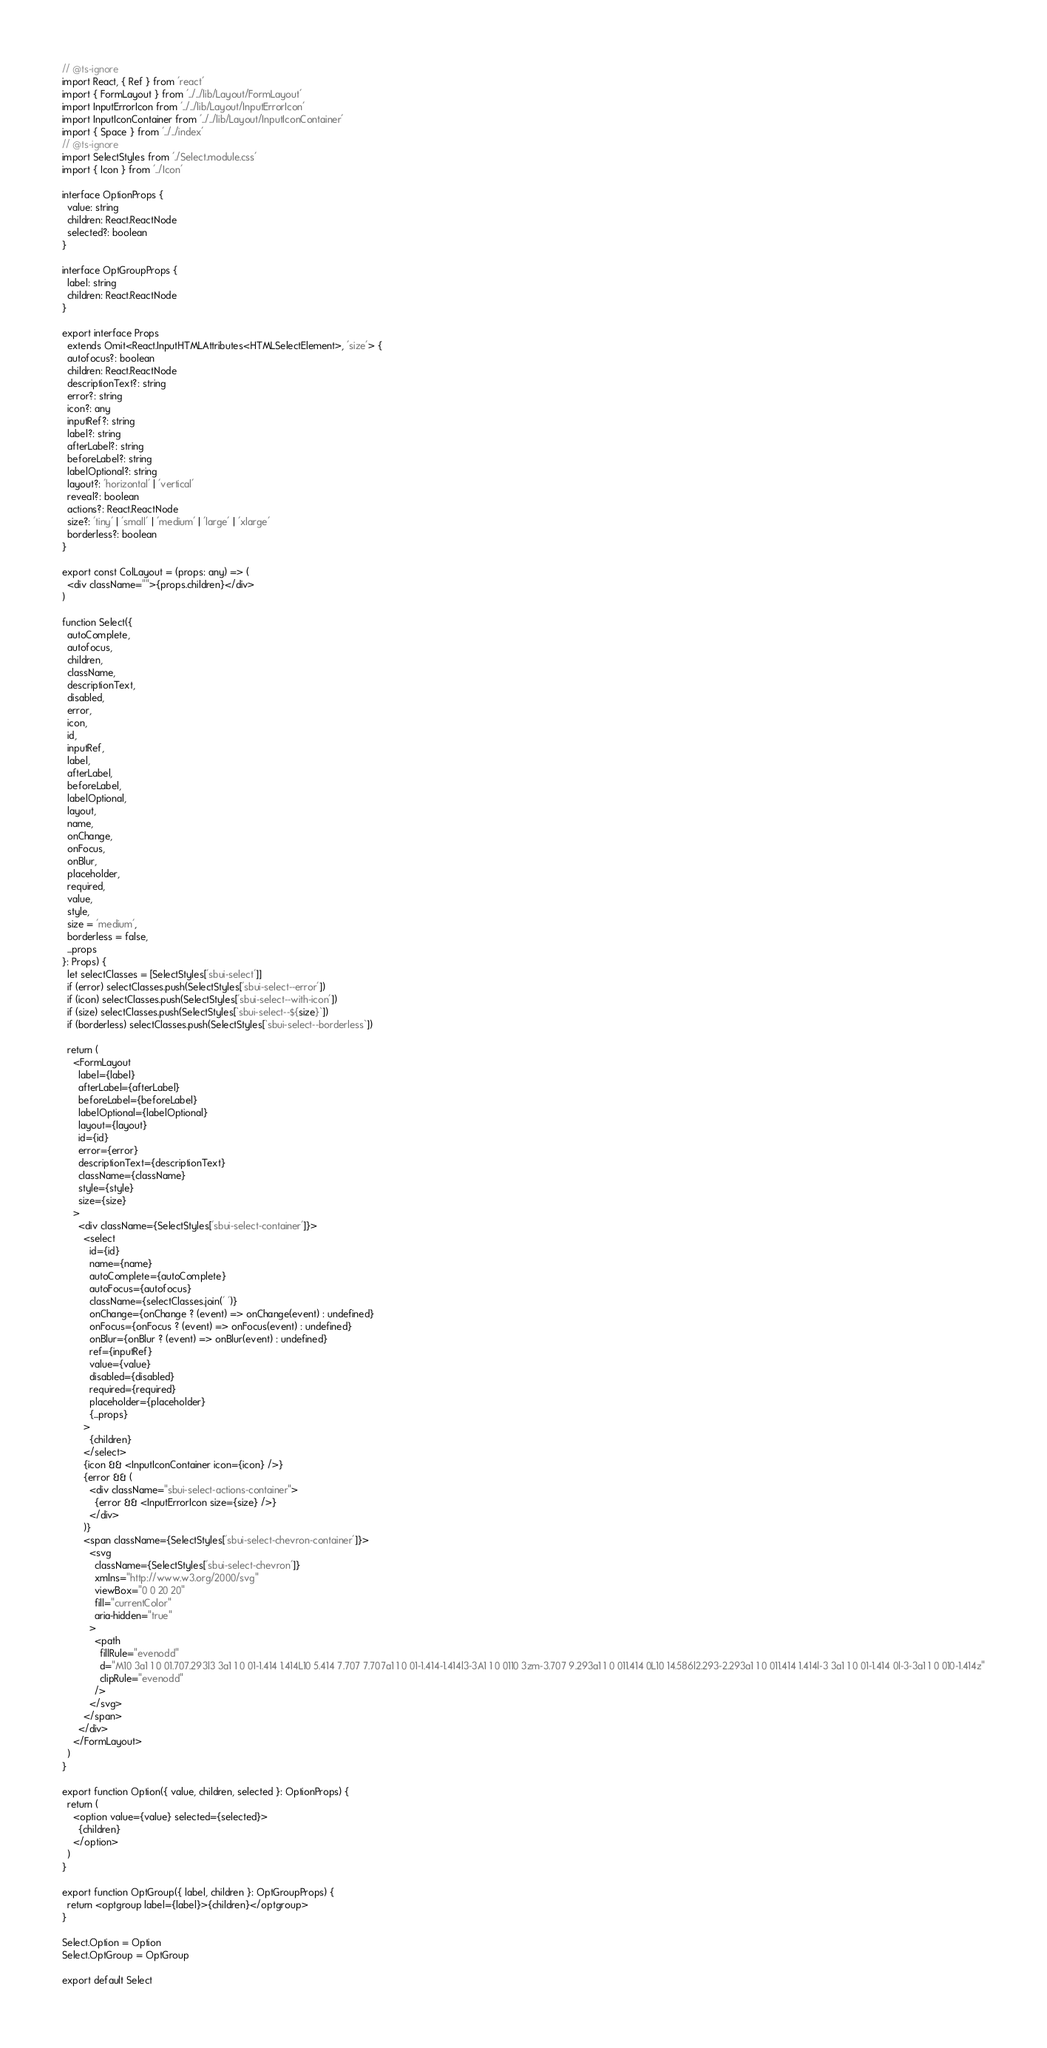Convert code to text. <code><loc_0><loc_0><loc_500><loc_500><_TypeScript_>// @ts-ignore
import React, { Ref } from 'react'
import { FormLayout } from '../../lib/Layout/FormLayout'
import InputErrorIcon from '../../lib/Layout/InputErrorIcon'
import InputIconContainer from '../../lib/Layout/InputIconContainer'
import { Space } from '../../index'
// @ts-ignore
import SelectStyles from './Select.module.css'
import { Icon } from '../Icon'

interface OptionProps {
  value: string
  children: React.ReactNode
  selected?: boolean
}

interface OptGroupProps {
  label: string
  children: React.ReactNode
}

export interface Props
  extends Omit<React.InputHTMLAttributes<HTMLSelectElement>, 'size'> {
  autofocus?: boolean
  children: React.ReactNode
  descriptionText?: string
  error?: string
  icon?: any
  inputRef?: string
  label?: string
  afterLabel?: string
  beforeLabel?: string
  labelOptional?: string
  layout?: 'horizontal' | 'vertical'
  reveal?: boolean
  actions?: React.ReactNode
  size?: 'tiny' | 'small' | 'medium' | 'large' | 'xlarge'
  borderless?: boolean
}

export const ColLayout = (props: any) => (
  <div className="">{props.children}</div>
)

function Select({
  autoComplete,
  autofocus,
  children,
  className,
  descriptionText,
  disabled,
  error,
  icon,
  id,
  inputRef,
  label,
  afterLabel,
  beforeLabel,
  labelOptional,
  layout,
  name,
  onChange,
  onFocus,
  onBlur,
  placeholder,
  required,
  value,
  style,
  size = 'medium',
  borderless = false,
  ...props
}: Props) {
  let selectClasses = [SelectStyles['sbui-select']]
  if (error) selectClasses.push(SelectStyles['sbui-select--error'])
  if (icon) selectClasses.push(SelectStyles['sbui-select--with-icon'])
  if (size) selectClasses.push(SelectStyles[`sbui-select--${size}`])
  if (borderless) selectClasses.push(SelectStyles[`sbui-select--borderless`])

  return (
    <FormLayout
      label={label}
      afterLabel={afterLabel}
      beforeLabel={beforeLabel}
      labelOptional={labelOptional}
      layout={layout}
      id={id}
      error={error}
      descriptionText={descriptionText}
      className={className}
      style={style}
      size={size}
    >
      <div className={SelectStyles['sbui-select-container']}>
        <select
          id={id}
          name={name}
          autoComplete={autoComplete}
          autoFocus={autofocus}
          className={selectClasses.join(' ')}
          onChange={onChange ? (event) => onChange(event) : undefined}
          onFocus={onFocus ? (event) => onFocus(event) : undefined}
          onBlur={onBlur ? (event) => onBlur(event) : undefined}
          ref={inputRef}
          value={value}
          disabled={disabled}
          required={required}
          placeholder={placeholder}
          {...props}
        >
          {children}
        </select>
        {icon && <InputIconContainer icon={icon} />}
        {error && (
          <div className="sbui-select-actions-container">
            {error && <InputErrorIcon size={size} />}
          </div>
        )}
        <span className={SelectStyles['sbui-select-chevron-container']}>
          <svg
            className={SelectStyles['sbui-select-chevron']}
            xmlns="http://www.w3.org/2000/svg"
            viewBox="0 0 20 20"
            fill="currentColor"
            aria-hidden="true"
          >
            <path
              fillRule="evenodd"
              d="M10 3a1 1 0 01.707.293l3 3a1 1 0 01-1.414 1.414L10 5.414 7.707 7.707a1 1 0 01-1.414-1.414l3-3A1 1 0 0110 3zm-3.707 9.293a1 1 0 011.414 0L10 14.586l2.293-2.293a1 1 0 011.414 1.414l-3 3a1 1 0 01-1.414 0l-3-3a1 1 0 010-1.414z"
              clipRule="evenodd"
            />
          </svg>
        </span>
      </div>
    </FormLayout>
  )
}

export function Option({ value, children, selected }: OptionProps) {
  return (
    <option value={value} selected={selected}>
      {children}
    </option>
  )
}

export function OptGroup({ label, children }: OptGroupProps) {
  return <optgroup label={label}>{children}</optgroup>
}

Select.Option = Option
Select.OptGroup = OptGroup

export default Select
</code> 